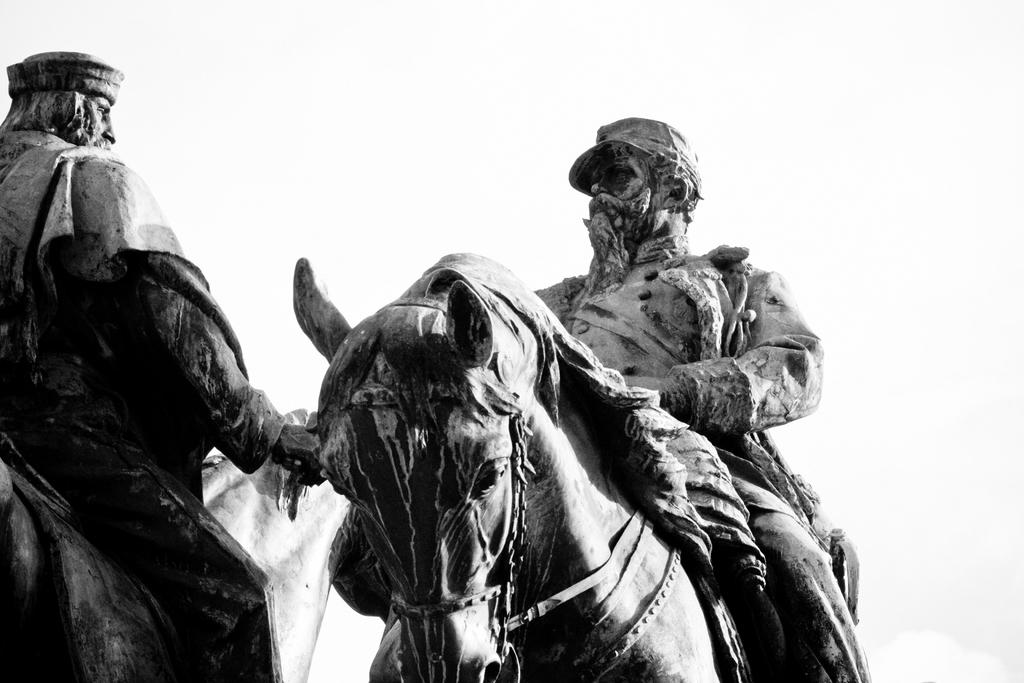What is the main subject of the image? The main subject of the image is a person sitting on a horse. What is the person on the horse doing? The person on the horse is waving his hand. Are there any other people in the image? Yes, there is another person in the image. What can be observed about the person with the horse? The person with the horse has a cap and a beard. What type of object is depicted in the image? The image depicts a statue. What type of brass instrument can be heard playing in the background of the image? There is no brass instrument or sound present in the image, as it is a statue depicting a person on a horse. 